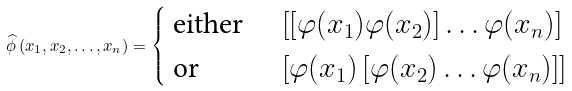Convert formula to latex. <formula><loc_0><loc_0><loc_500><loc_500>\widehat { \phi } \left ( x _ { 1 } , x _ { 2 } , \dots , x _ { n } \right ) = \begin{cases} \text { either } & \left [ \left [ \varphi ( x _ { 1 } ) \varphi ( x _ { 2 } ) \right ] \dots \varphi ( x _ { n } ) \right ] \\ \text { or } & \left [ \varphi ( x _ { 1 } ) \left [ \varphi ( x _ { 2 } ) \dots \varphi ( x _ { n } ) \right ] \right ] \end{cases}</formula> 